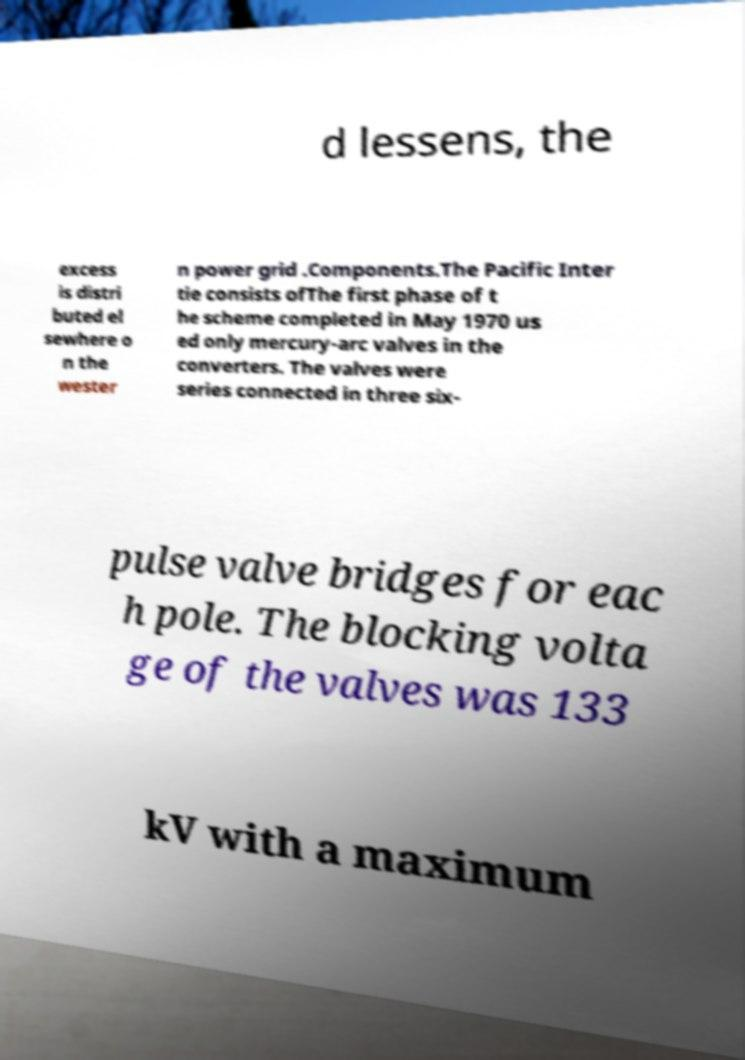There's text embedded in this image that I need extracted. Can you transcribe it verbatim? d lessens, the excess is distri buted el sewhere o n the wester n power grid .Components.The Pacific Inter tie consists ofThe first phase of t he scheme completed in May 1970 us ed only mercury-arc valves in the converters. The valves were series connected in three six- pulse valve bridges for eac h pole. The blocking volta ge of the valves was 133 kV with a maximum 